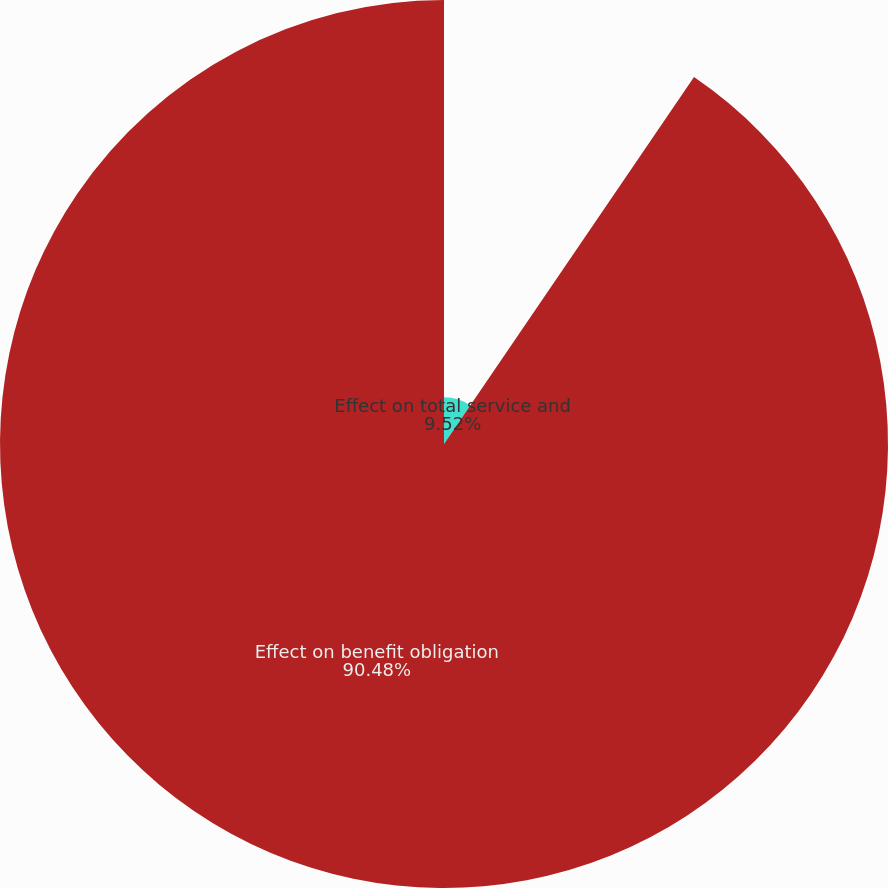Convert chart. <chart><loc_0><loc_0><loc_500><loc_500><pie_chart><fcel>Effect on total service and<fcel>Effect on benefit obligation<nl><fcel>9.52%<fcel>90.48%<nl></chart> 